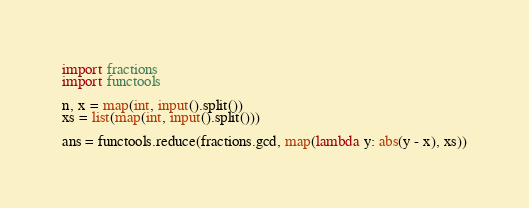<code> <loc_0><loc_0><loc_500><loc_500><_Python_>import fractions
import functools

n, x = map(int, input().split())
xs = list(map(int, input().split()))

ans = functools.reduce(fractions.gcd, map(lambda y: abs(y - x), xs))</code> 